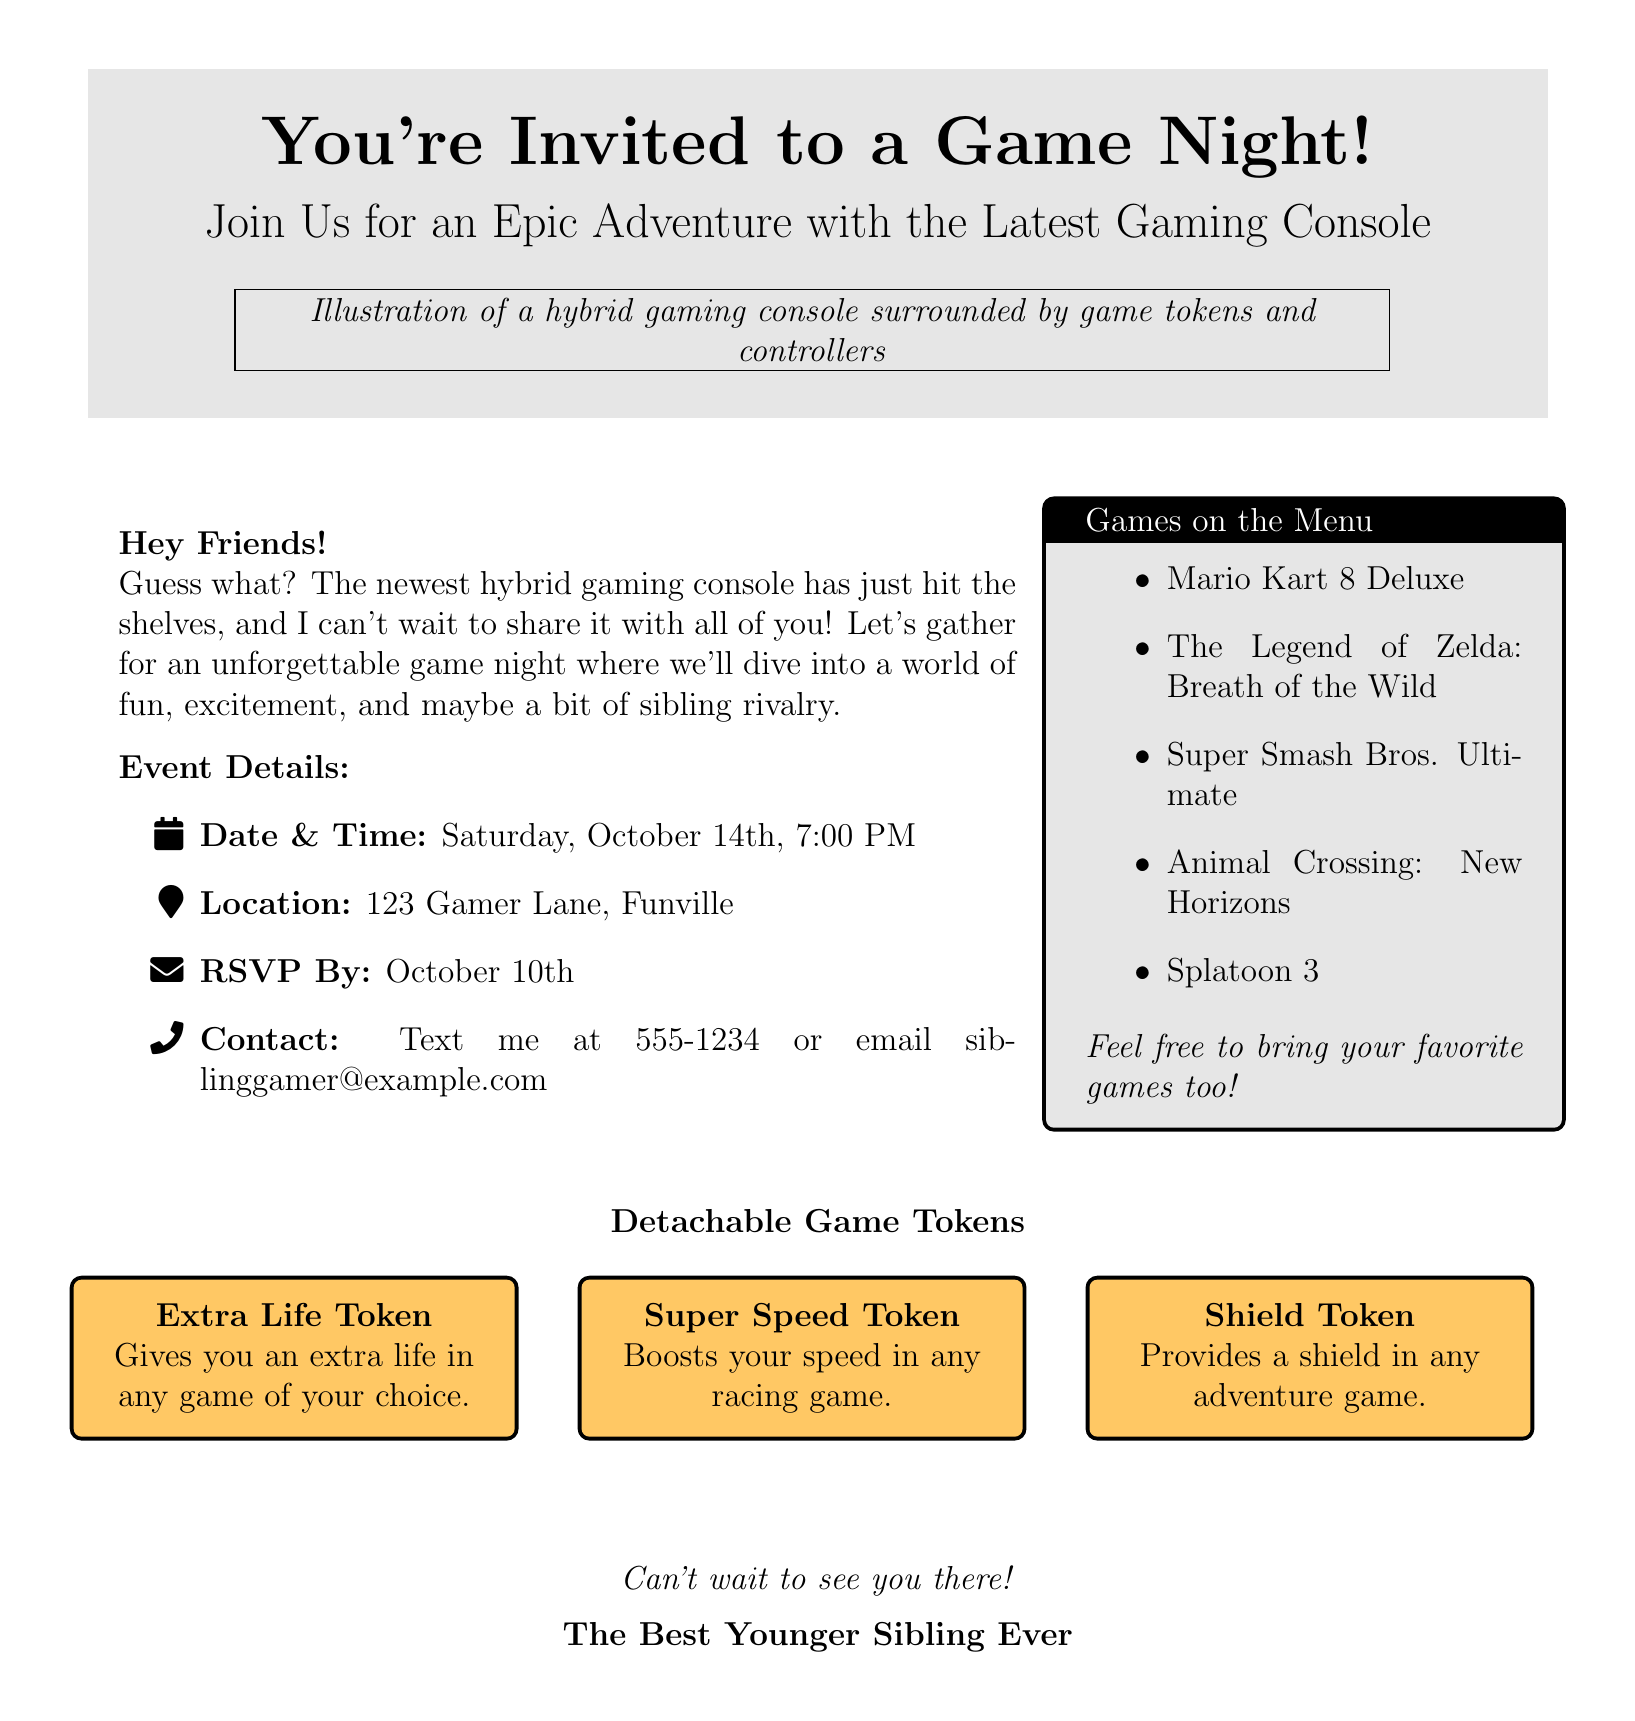what is the date and time of the game night? The document provides specific details about the event, including the date and time.
Answer: Saturday, October 14th, 7:00 PM where is the game night being held? The location of the event is clearly stated in the document.
Answer: 123 Gamer Lane, Funville what games are mentioned in the document? The document lists several games that will be played during the event.
Answer: Mario Kart 8 Deluxe, The Legend of Zelda: Breath of the Wild, Super Smash Bros. Ultimate, Animal Crossing: New Horizons, Splatoon 3 what is the RSVP deadline? The invitation specifies the date by which attendees should respond.
Answer: October 10th what type of tokens are included in the game night? The document describes the various detachable game tokens that guests can use.
Answer: Extra Life Token, Super Speed Token, Shield Token who is sending the invitation? The closing statement of the card reveals the sender's relationship to the recipients.
Answer: The Best Younger Sibling Ever how can attendees contact the sender? The document provides contact information for the sender of the invitation.
Answer: Text me at 555-1234 or email siblinggamer@example.com what is the theme of the game night? The document mentions the theme of the gathering in the opening invitation text.
Answer: Epic Adventure with the Latest Gaming Console 